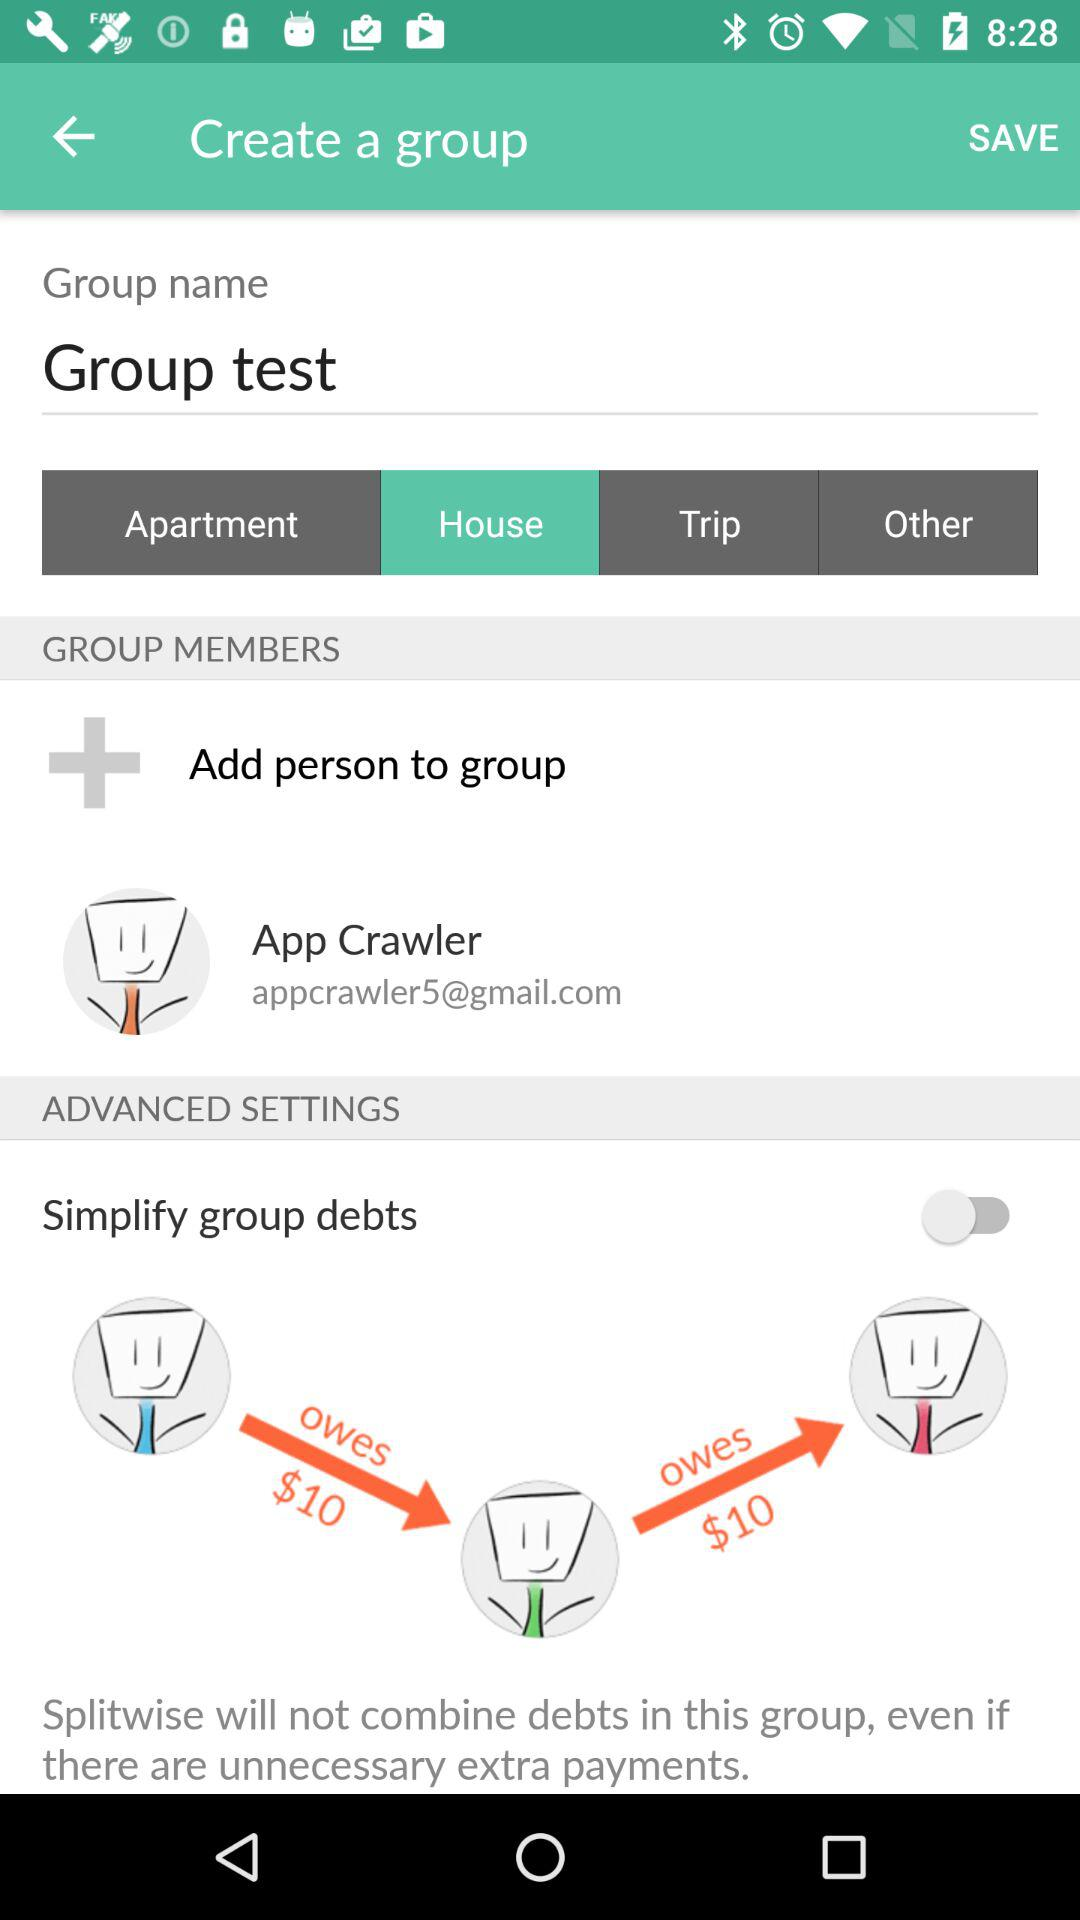What is the status of "Simplify group debts"? The status is "off". 